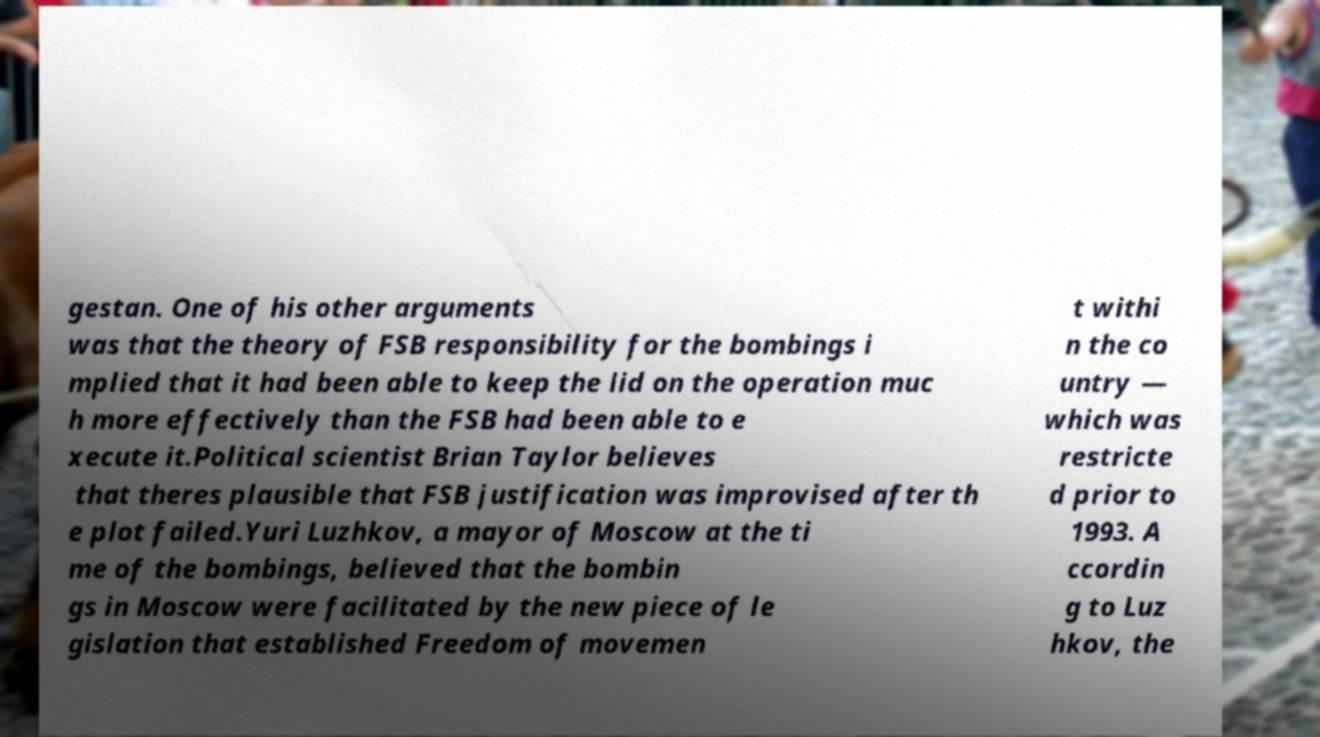Could you assist in decoding the text presented in this image and type it out clearly? gestan. One of his other arguments was that the theory of FSB responsibility for the bombings i mplied that it had been able to keep the lid on the operation muc h more effectively than the FSB had been able to e xecute it.Political scientist Brian Taylor believes that theres plausible that FSB justification was improvised after th e plot failed.Yuri Luzhkov, a mayor of Moscow at the ti me of the bombings, believed that the bombin gs in Moscow were facilitated by the new piece of le gislation that established Freedom of movemen t withi n the co untry — which was restricte d prior to 1993. A ccordin g to Luz hkov, the 